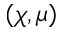Convert formula to latex. <formula><loc_0><loc_0><loc_500><loc_500>( \chi , \mu )</formula> 